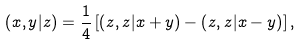<formula> <loc_0><loc_0><loc_500><loc_500>\left ( x , y | z \right ) = \frac { 1 } { 4 } \left [ \left ( z , z | x + y \right ) - \left ( z , z | x - y \right ) \right ] ,</formula> 